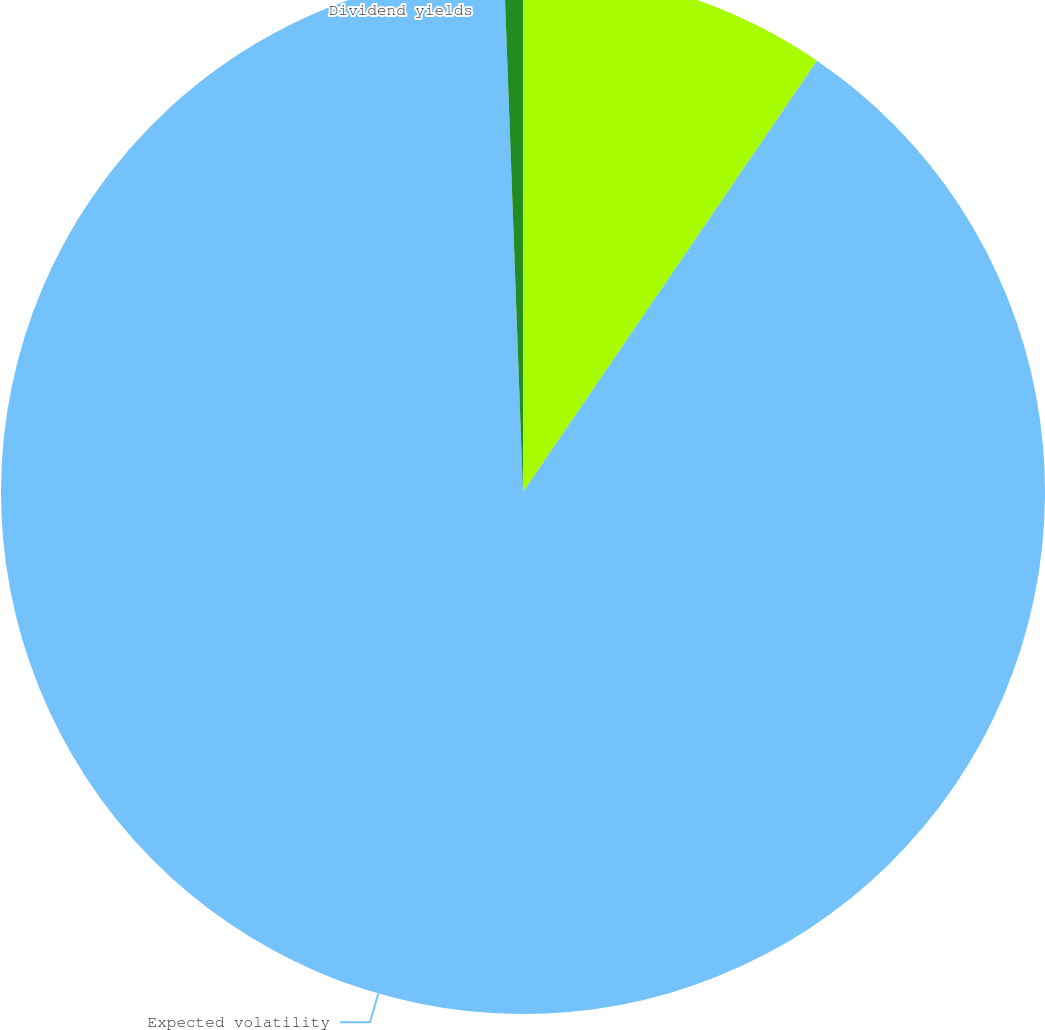Convert chart. <chart><loc_0><loc_0><loc_500><loc_500><pie_chart><fcel>Risk-free interest rates<fcel>Expected volatility<fcel>Dividend yields<nl><fcel>9.52%<fcel>89.9%<fcel>0.58%<nl></chart> 